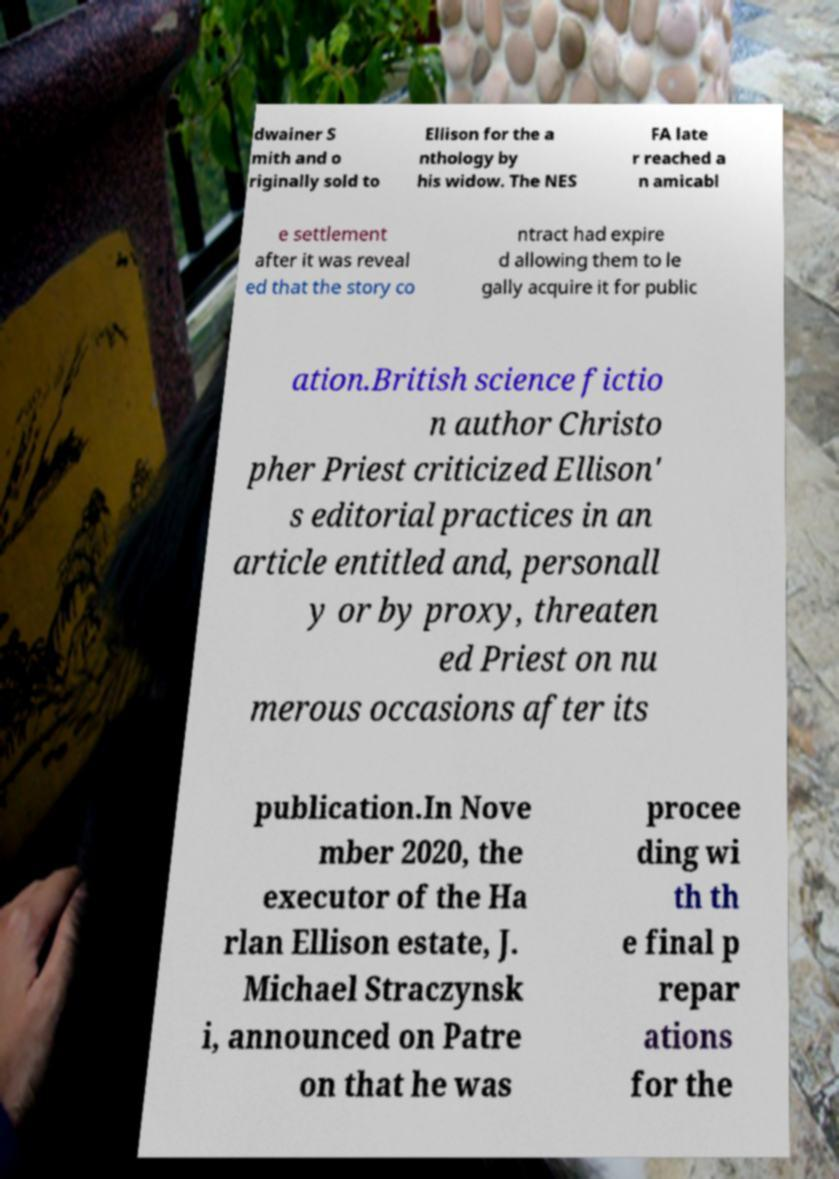I need the written content from this picture converted into text. Can you do that? dwainer S mith and o riginally sold to Ellison for the a nthology by his widow. The NES FA late r reached a n amicabl e settlement after it was reveal ed that the story co ntract had expire d allowing them to le gally acquire it for public ation.British science fictio n author Christo pher Priest criticized Ellison' s editorial practices in an article entitled and, personall y or by proxy, threaten ed Priest on nu merous occasions after its publication.In Nove mber 2020, the executor of the Ha rlan Ellison estate, J. Michael Straczynsk i, announced on Patre on that he was procee ding wi th th e final p repar ations for the 